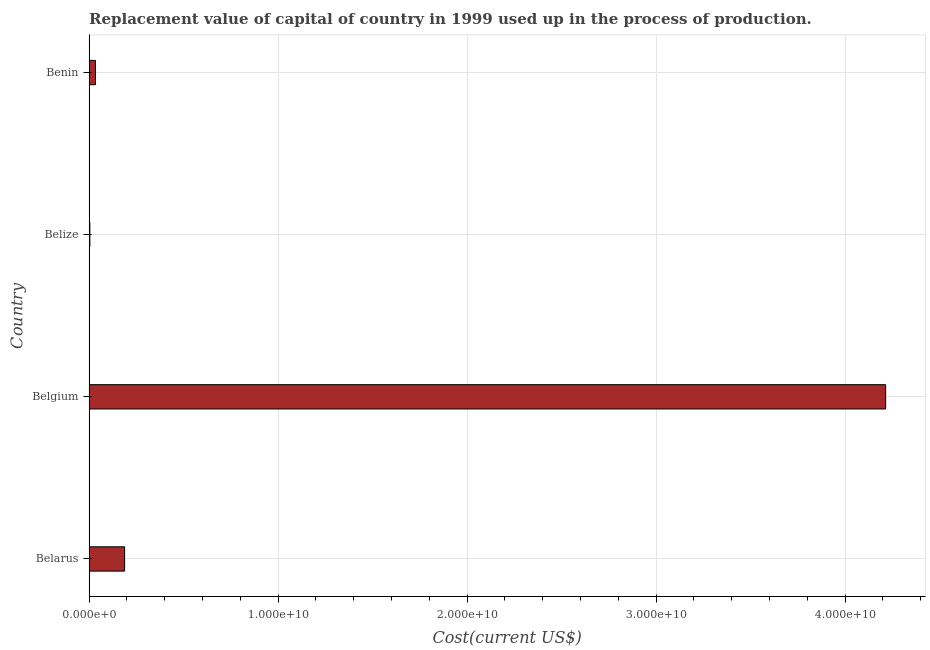What is the title of the graph?
Provide a succinct answer. Replacement value of capital of country in 1999 used up in the process of production. What is the label or title of the X-axis?
Provide a short and direct response. Cost(current US$). What is the consumption of fixed capital in Belarus?
Provide a short and direct response. 1.88e+09. Across all countries, what is the maximum consumption of fixed capital?
Ensure brevity in your answer.  4.21e+1. Across all countries, what is the minimum consumption of fixed capital?
Your answer should be very brief. 4.07e+07. In which country was the consumption of fixed capital maximum?
Provide a short and direct response. Belgium. In which country was the consumption of fixed capital minimum?
Offer a very short reply. Belize. What is the sum of the consumption of fixed capital?
Provide a succinct answer. 4.44e+1. What is the difference between the consumption of fixed capital in Belgium and Belize?
Ensure brevity in your answer.  4.21e+1. What is the average consumption of fixed capital per country?
Offer a very short reply. 1.11e+1. What is the median consumption of fixed capital?
Provide a succinct answer. 1.11e+09. What is the ratio of the consumption of fixed capital in Belarus to that in Belize?
Give a very brief answer. 46.23. What is the difference between the highest and the second highest consumption of fixed capital?
Your answer should be very brief. 4.03e+1. Is the sum of the consumption of fixed capital in Belize and Benin greater than the maximum consumption of fixed capital across all countries?
Provide a short and direct response. No. What is the difference between the highest and the lowest consumption of fixed capital?
Your answer should be very brief. 4.21e+1. Are all the bars in the graph horizontal?
Offer a very short reply. Yes. How many countries are there in the graph?
Your response must be concise. 4. What is the difference between two consecutive major ticks on the X-axis?
Keep it short and to the point. 1.00e+1. Are the values on the major ticks of X-axis written in scientific E-notation?
Make the answer very short. Yes. What is the Cost(current US$) of Belarus?
Provide a succinct answer. 1.88e+09. What is the Cost(current US$) in Belgium?
Provide a succinct answer. 4.21e+1. What is the Cost(current US$) of Belize?
Ensure brevity in your answer.  4.07e+07. What is the Cost(current US$) of Benin?
Your response must be concise. 3.37e+08. What is the difference between the Cost(current US$) in Belarus and Belgium?
Offer a very short reply. -4.03e+1. What is the difference between the Cost(current US$) in Belarus and Belize?
Your answer should be compact. 1.84e+09. What is the difference between the Cost(current US$) in Belarus and Benin?
Make the answer very short. 1.54e+09. What is the difference between the Cost(current US$) in Belgium and Belize?
Give a very brief answer. 4.21e+1. What is the difference between the Cost(current US$) in Belgium and Benin?
Keep it short and to the point. 4.18e+1. What is the difference between the Cost(current US$) in Belize and Benin?
Provide a succinct answer. -2.97e+08. What is the ratio of the Cost(current US$) in Belarus to that in Belgium?
Offer a terse response. 0.04. What is the ratio of the Cost(current US$) in Belarus to that in Belize?
Your answer should be very brief. 46.23. What is the ratio of the Cost(current US$) in Belarus to that in Benin?
Provide a succinct answer. 5.57. What is the ratio of the Cost(current US$) in Belgium to that in Belize?
Your response must be concise. 1036.77. What is the ratio of the Cost(current US$) in Belgium to that in Benin?
Ensure brevity in your answer.  124.96. What is the ratio of the Cost(current US$) in Belize to that in Benin?
Your answer should be very brief. 0.12. 